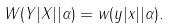Convert formula to latex. <formula><loc_0><loc_0><loc_500><loc_500>W ( Y | X | | \alpha ) = w ( y | x | | \alpha ) .</formula> 